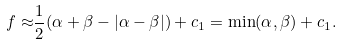Convert formula to latex. <formula><loc_0><loc_0><loc_500><loc_500>f \approx & \frac { 1 } { 2 } ( \alpha + \beta - | \alpha - \beta | ) + c _ { 1 } = \min ( \alpha , \beta ) + c _ { 1 } .</formula> 